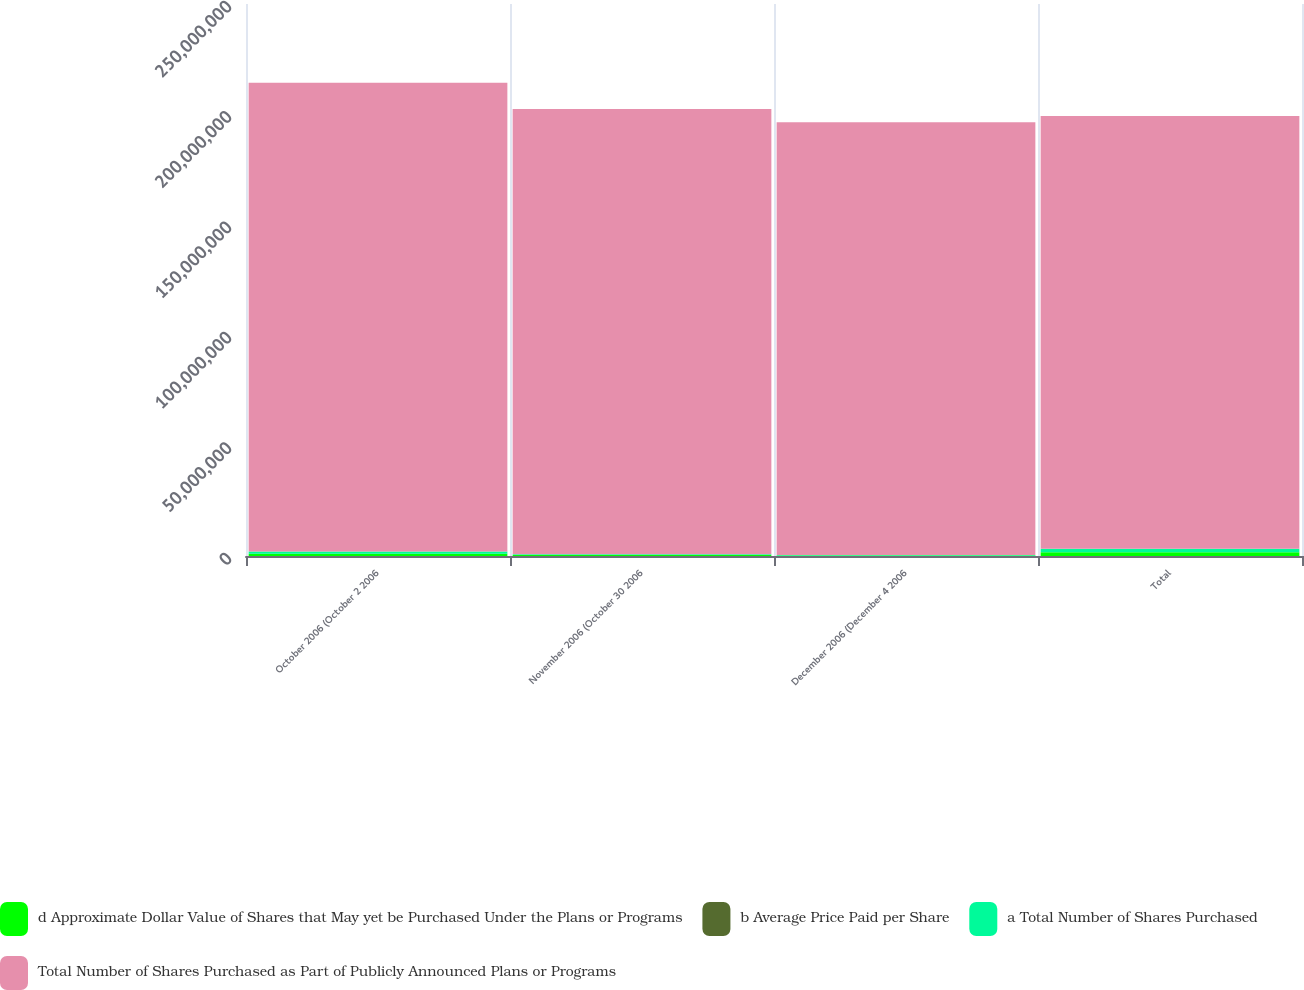Convert chart. <chart><loc_0><loc_0><loc_500><loc_500><stacked_bar_chart><ecel><fcel>October 2006 (October 2 2006<fcel>November 2006 (October 30 2006<fcel>December 2006 (December 4 2006<fcel>Total<nl><fcel>d Approximate Dollar Value of Shares that May yet be Purchased Under the Plans or Programs<fcel>1.05512e+06<fcel>404769<fcel>210100<fcel>1.66999e+06<nl><fcel>b Average Price Paid per Share<fcel>22.98<fcel>26.84<fcel>26.82<fcel>24.4<nl><fcel>a Total Number of Shares Purchased<fcel>1.01e+06<fcel>395000<fcel>210100<fcel>1.6151e+06<nl><fcel>Total Number of Shares Purchased as Part of Publicly Announced Plans or Programs<fcel>2.12217e+08<fcel>2.01616e+08<fcel>1.95981e+08<fcel>1.95981e+08<nl></chart> 